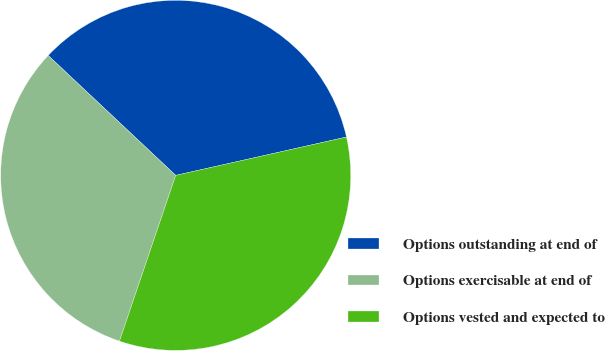Convert chart. <chart><loc_0><loc_0><loc_500><loc_500><pie_chart><fcel>Options outstanding at end of<fcel>Options exercisable at end of<fcel>Options vested and expected to<nl><fcel>34.48%<fcel>31.81%<fcel>33.72%<nl></chart> 